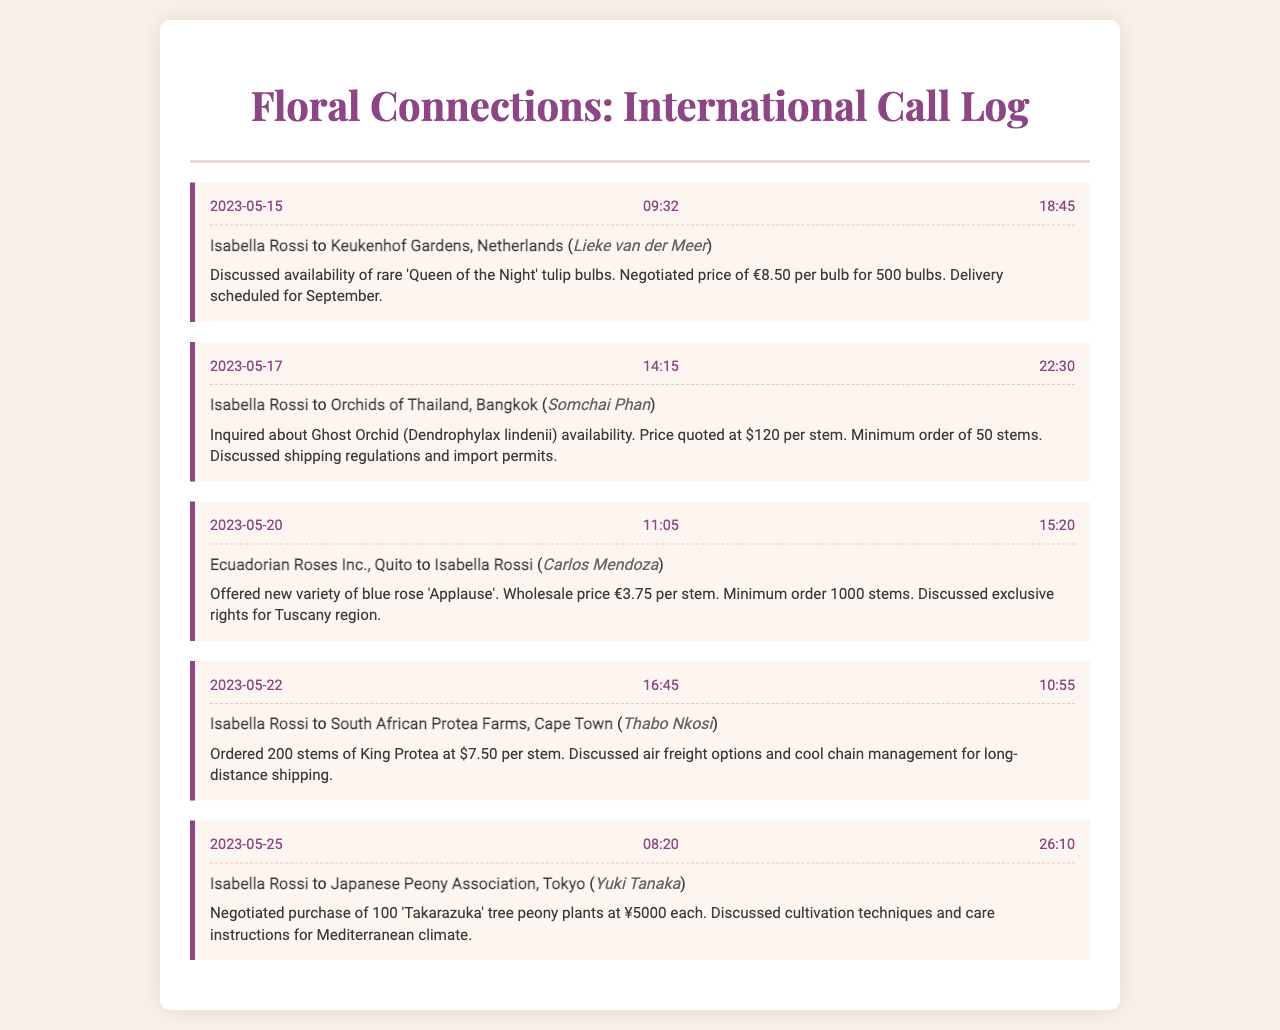what is the name of the recipient from Keukenhof Gardens? The recipient from Keukenhof Gardens is mentioned in the call entry on 2023-05-15.
Answer: Lieke van der Meer what is the price of the Ghost Orchid per stem? The price for the Ghost Orchid is listed in the call entry on 2023-05-17.
Answer: $120 how many King Protea stems were ordered? The number of King Protea stems is stated in the call entry on 2023-05-22.
Answer: 200 which flower was discussed with Ecuadorian Roses Inc.? The flower discussed in the call entry on 2023-05-20 is noted.
Answer: blue rose 'Applause' on what date was the call made to Orchids of Thailand? The date of the call to Orchids of Thailand can be found in the call entry.
Answer: 2023-05-17 what was the duration of the call to South African Protea Farms? The duration of the call made to South African Protea Farms is recorded in the call entry.
Answer: 10:55 what type of plants were negotiated in the call with the Japanese Peony Association? The type of plants mentioned in the call entry on 2023-05-25 is described.
Answer: 'Takarazuka' tree peony who called Isabella Rossi from Ecuadorian Roses Inc.? The caller from Ecuadorian Roses Inc. during the call entry is indicated.
Answer: Carlos Mendoza what minimum order was discussed for the Ghost Orchid? The minimum order quantity for the Ghost Orchid is specified in the call entry.
Answer: 50 stems 